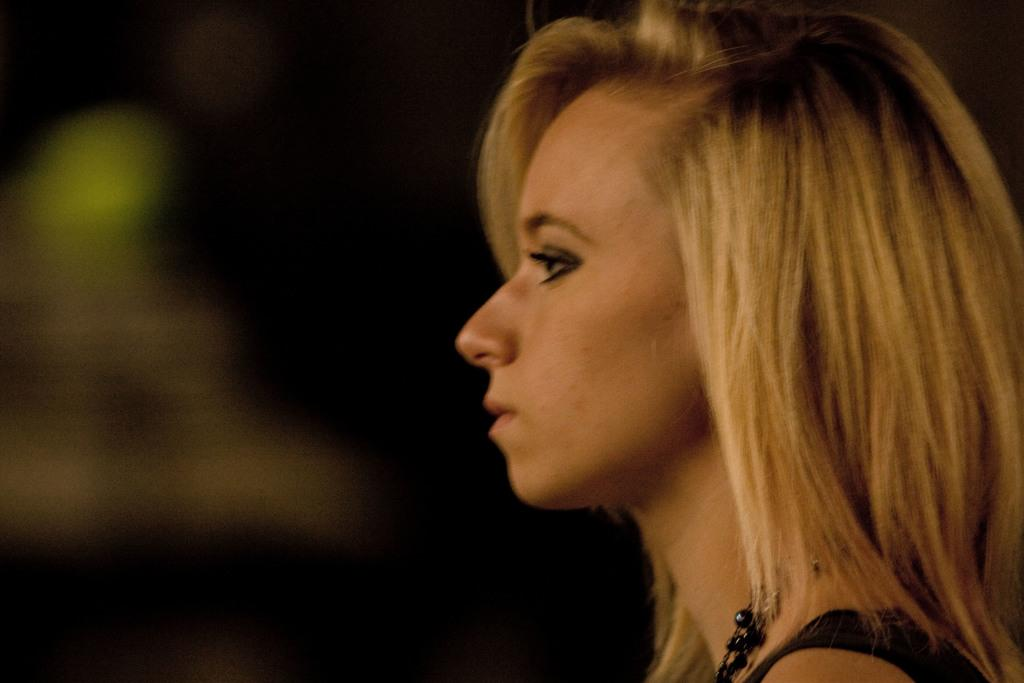Who or what is the main subject in the image? There is a person in the image. What is the person wearing? The person is wearing a black dress and a chain. Can you describe the background of the image? The background of the image is blurry. What type of shoe is the person wearing in the image? There is no shoe visible in the image; the person's attire is described as a black dress and a chain. 